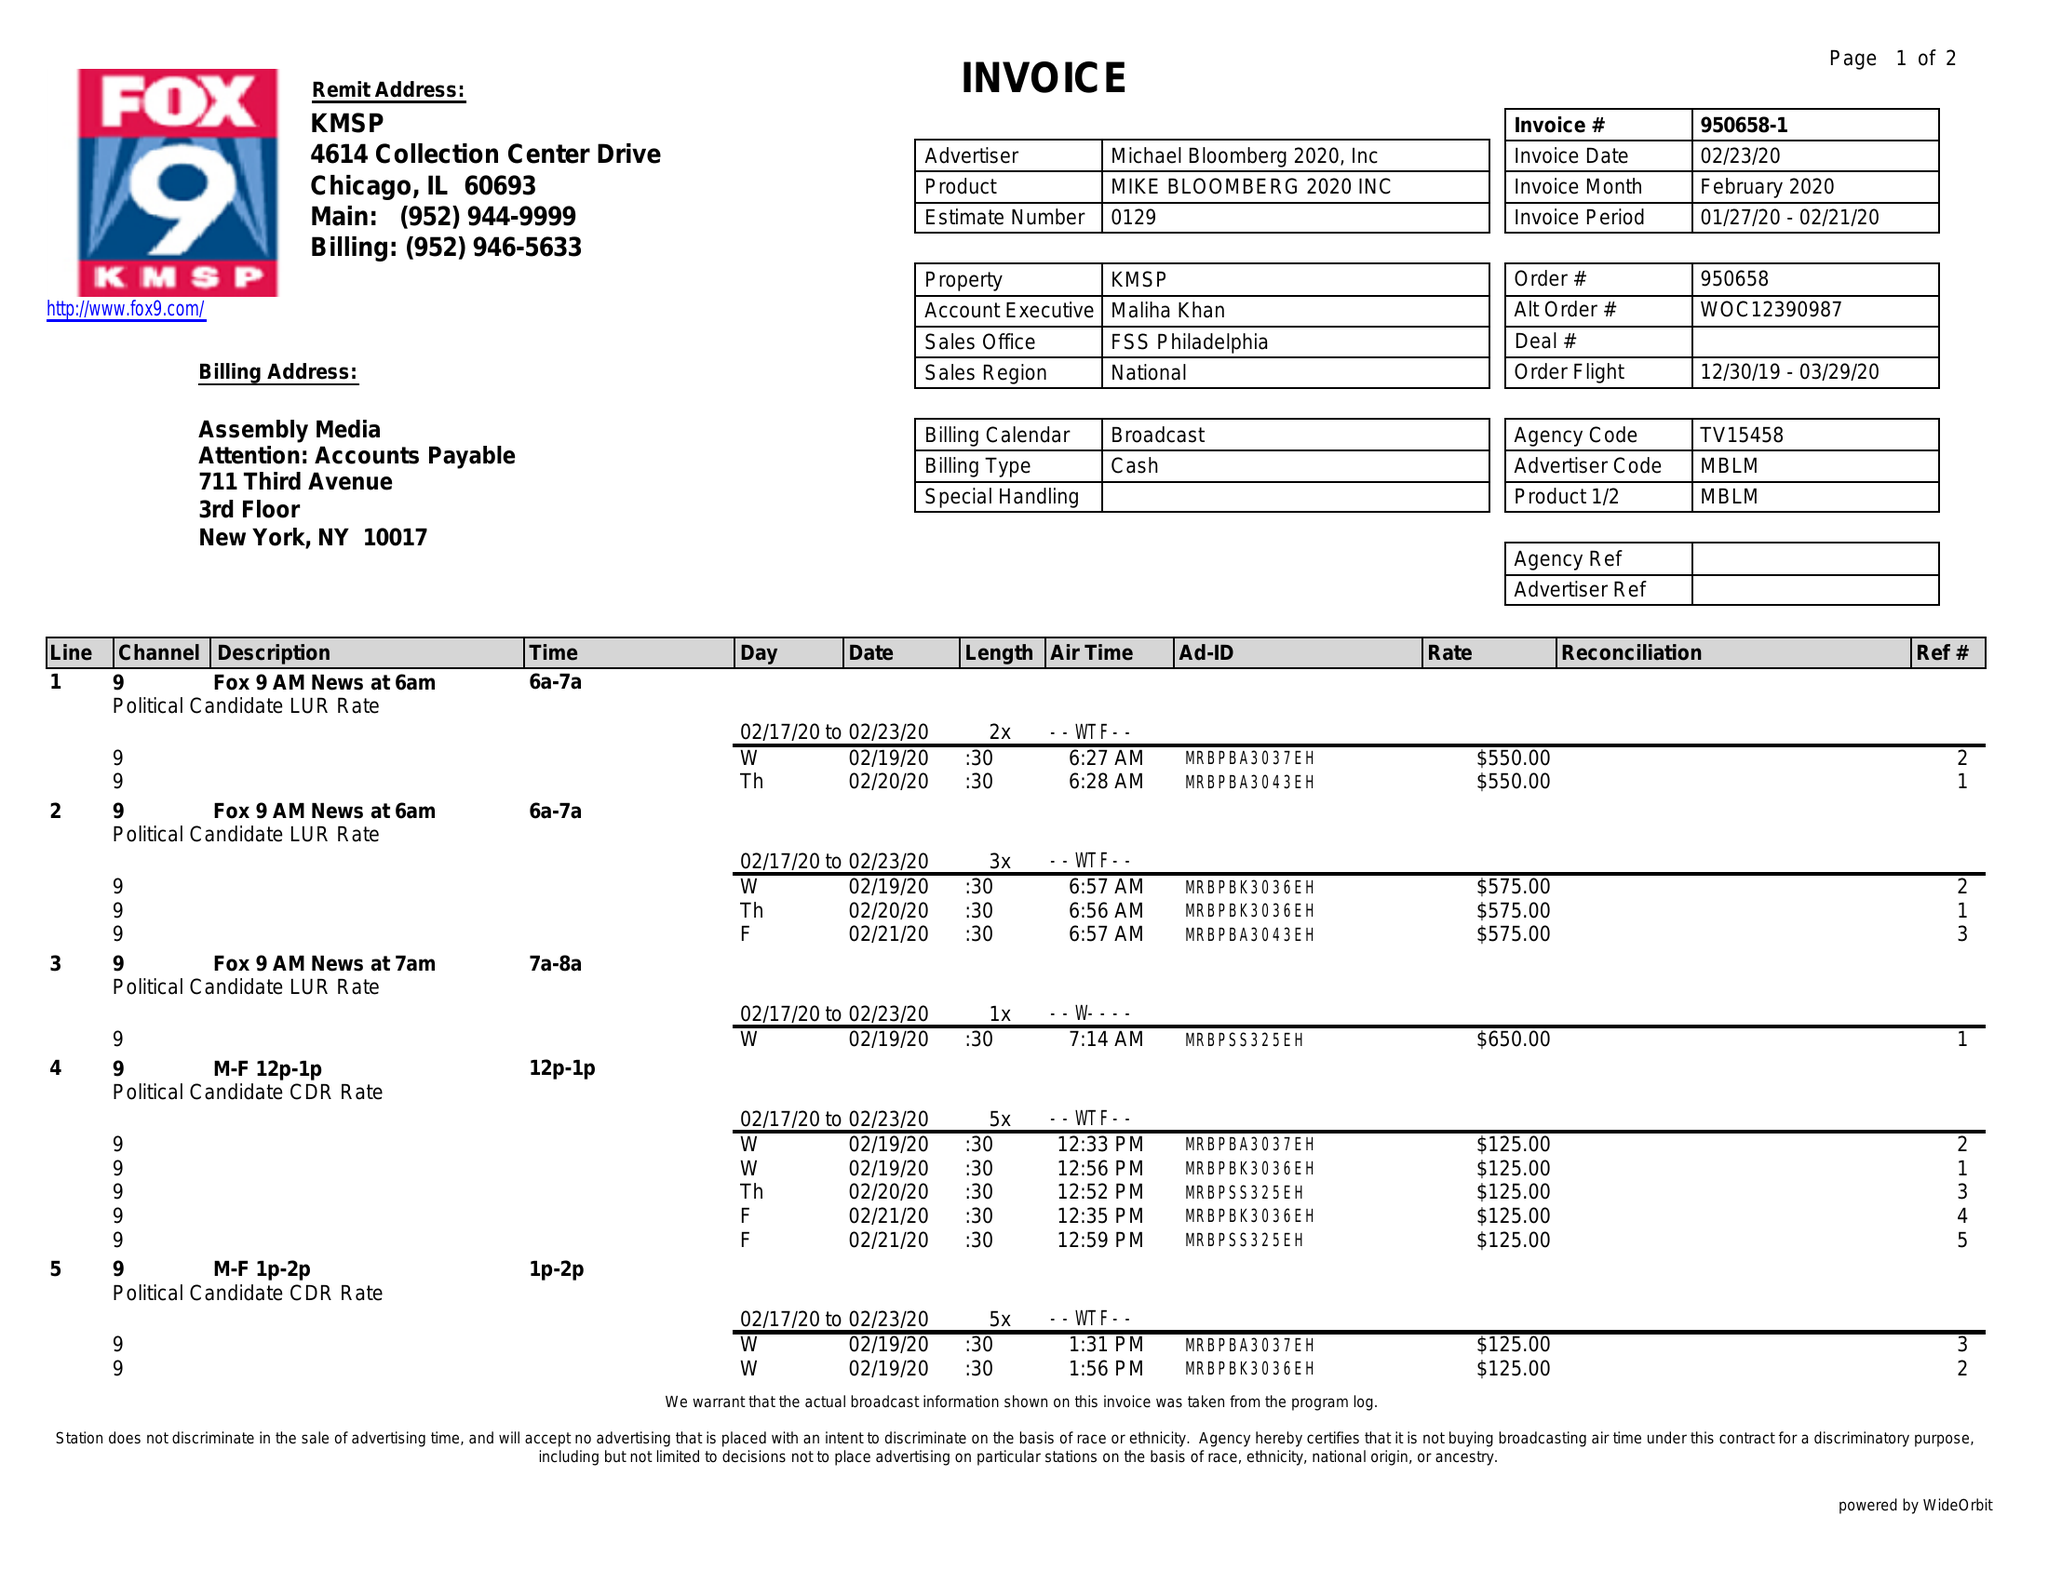What is the value for the advertiser?
Answer the question using a single word or phrase. MICHAEL BLOOMBERG 2020, INC 